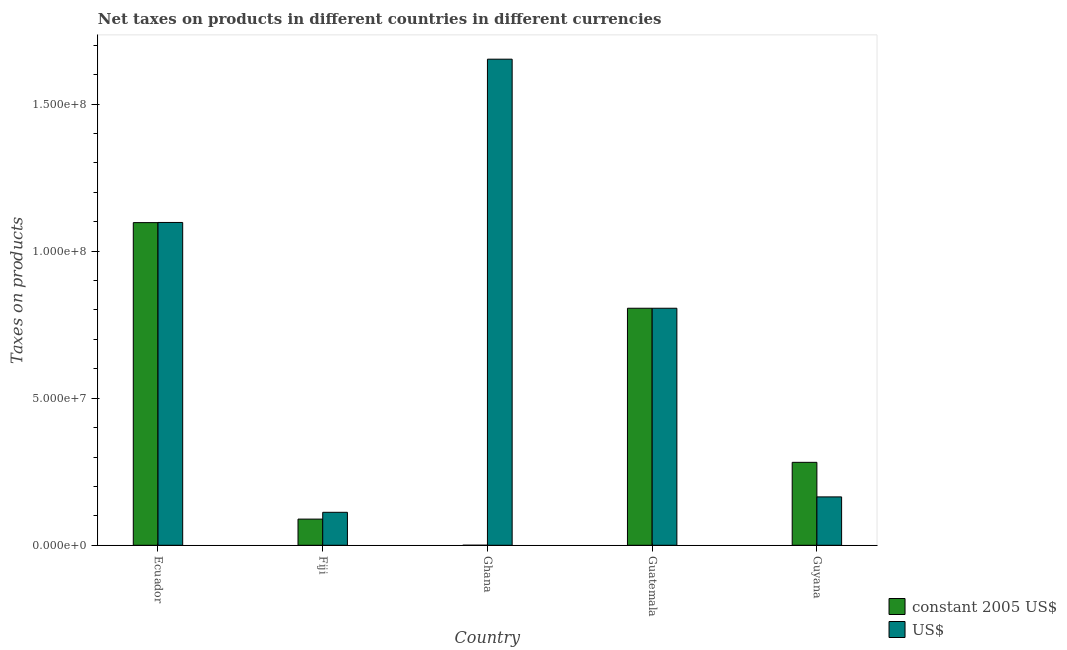How many different coloured bars are there?
Offer a very short reply. 2. How many groups of bars are there?
Keep it short and to the point. 5. How many bars are there on the 3rd tick from the left?
Offer a terse response. 2. How many bars are there on the 1st tick from the right?
Offer a terse response. 2. What is the label of the 4th group of bars from the left?
Your answer should be very brief. Guatemala. In how many cases, is the number of bars for a given country not equal to the number of legend labels?
Keep it short and to the point. 0. What is the net taxes in constant 2005 us$ in Guatemala?
Provide a short and direct response. 8.06e+07. Across all countries, what is the maximum net taxes in constant 2005 us$?
Your answer should be compact. 1.10e+08. Across all countries, what is the minimum net taxes in us$?
Keep it short and to the point. 1.12e+07. In which country was the net taxes in us$ maximum?
Give a very brief answer. Ghana. In which country was the net taxes in us$ minimum?
Your response must be concise. Fiji. What is the total net taxes in us$ in the graph?
Offer a terse response. 3.83e+08. What is the difference between the net taxes in us$ in Ecuador and that in Fiji?
Make the answer very short. 9.86e+07. What is the difference between the net taxes in us$ in Fiji and the net taxes in constant 2005 us$ in Guatemala?
Make the answer very short. -6.94e+07. What is the average net taxes in constant 2005 us$ per country?
Your response must be concise. 4.55e+07. What is the difference between the net taxes in us$ and net taxes in constant 2005 us$ in Fiji?
Provide a short and direct response. 2.31e+06. In how many countries, is the net taxes in constant 2005 us$ greater than 40000000 units?
Make the answer very short. 2. What is the ratio of the net taxes in constant 2005 us$ in Ecuador to that in Guatemala?
Offer a terse response. 1.36. Is the net taxes in constant 2005 us$ in Fiji less than that in Guyana?
Your answer should be compact. Yes. Is the difference between the net taxes in us$ in Ecuador and Ghana greater than the difference between the net taxes in constant 2005 us$ in Ecuador and Ghana?
Give a very brief answer. No. What is the difference between the highest and the second highest net taxes in constant 2005 us$?
Provide a succinct answer. 2.91e+07. What is the difference between the highest and the lowest net taxes in us$?
Keep it short and to the point. 1.54e+08. In how many countries, is the net taxes in us$ greater than the average net taxes in us$ taken over all countries?
Ensure brevity in your answer.  3. What does the 2nd bar from the left in Guatemala represents?
Offer a terse response. US$. What does the 2nd bar from the right in Ecuador represents?
Offer a very short reply. Constant 2005 us$. How many bars are there?
Give a very brief answer. 10. Are all the bars in the graph horizontal?
Ensure brevity in your answer.  No. How many countries are there in the graph?
Make the answer very short. 5. What is the difference between two consecutive major ticks on the Y-axis?
Your answer should be very brief. 5.00e+07. Are the values on the major ticks of Y-axis written in scientific E-notation?
Your answer should be compact. Yes. What is the title of the graph?
Keep it short and to the point. Net taxes on products in different countries in different currencies. Does "Commercial service exports" appear as one of the legend labels in the graph?
Provide a succinct answer. No. What is the label or title of the Y-axis?
Your response must be concise. Taxes on products. What is the Taxes on products of constant 2005 US$ in Ecuador?
Ensure brevity in your answer.  1.10e+08. What is the Taxes on products in US$ in Ecuador?
Make the answer very short. 1.10e+08. What is the Taxes on products of constant 2005 US$ in Fiji?
Ensure brevity in your answer.  8.90e+06. What is the Taxes on products in US$ in Fiji?
Your answer should be very brief. 1.12e+07. What is the Taxes on products in constant 2005 US$ in Ghana?
Your answer should be compact. 1.18e+04. What is the Taxes on products in US$ in Ghana?
Give a very brief answer. 1.65e+08. What is the Taxes on products in constant 2005 US$ in Guatemala?
Ensure brevity in your answer.  8.06e+07. What is the Taxes on products of US$ in Guatemala?
Your answer should be compact. 8.06e+07. What is the Taxes on products of constant 2005 US$ in Guyana?
Give a very brief answer. 2.82e+07. What is the Taxes on products of US$ in Guyana?
Provide a short and direct response. 1.64e+07. Across all countries, what is the maximum Taxes on products of constant 2005 US$?
Give a very brief answer. 1.10e+08. Across all countries, what is the maximum Taxes on products of US$?
Provide a short and direct response. 1.65e+08. Across all countries, what is the minimum Taxes on products in constant 2005 US$?
Keep it short and to the point. 1.18e+04. Across all countries, what is the minimum Taxes on products in US$?
Your answer should be very brief. 1.12e+07. What is the total Taxes on products in constant 2005 US$ in the graph?
Make the answer very short. 2.27e+08. What is the total Taxes on products of US$ in the graph?
Offer a terse response. 3.83e+08. What is the difference between the Taxes on products in constant 2005 US$ in Ecuador and that in Fiji?
Your response must be concise. 1.01e+08. What is the difference between the Taxes on products of US$ in Ecuador and that in Fiji?
Give a very brief answer. 9.86e+07. What is the difference between the Taxes on products in constant 2005 US$ in Ecuador and that in Ghana?
Keep it short and to the point. 1.10e+08. What is the difference between the Taxes on products in US$ in Ecuador and that in Ghana?
Provide a short and direct response. -5.55e+07. What is the difference between the Taxes on products in constant 2005 US$ in Ecuador and that in Guatemala?
Keep it short and to the point. 2.91e+07. What is the difference between the Taxes on products of US$ in Ecuador and that in Guatemala?
Your answer should be compact. 2.92e+07. What is the difference between the Taxes on products of constant 2005 US$ in Ecuador and that in Guyana?
Keep it short and to the point. 8.15e+07. What is the difference between the Taxes on products of US$ in Ecuador and that in Guyana?
Your answer should be compact. 9.33e+07. What is the difference between the Taxes on products of constant 2005 US$ in Fiji and that in Ghana?
Ensure brevity in your answer.  8.89e+06. What is the difference between the Taxes on products in US$ in Fiji and that in Ghana?
Your response must be concise. -1.54e+08. What is the difference between the Taxes on products in constant 2005 US$ in Fiji and that in Guatemala?
Offer a very short reply. -7.17e+07. What is the difference between the Taxes on products in US$ in Fiji and that in Guatemala?
Your answer should be very brief. -6.94e+07. What is the difference between the Taxes on products of constant 2005 US$ in Fiji and that in Guyana?
Offer a terse response. -1.93e+07. What is the difference between the Taxes on products in US$ in Fiji and that in Guyana?
Give a very brief answer. -5.24e+06. What is the difference between the Taxes on products in constant 2005 US$ in Ghana and that in Guatemala?
Give a very brief answer. -8.06e+07. What is the difference between the Taxes on products of US$ in Ghana and that in Guatemala?
Your answer should be compact. 8.47e+07. What is the difference between the Taxes on products in constant 2005 US$ in Ghana and that in Guyana?
Your answer should be compact. -2.82e+07. What is the difference between the Taxes on products of US$ in Ghana and that in Guyana?
Provide a succinct answer. 1.49e+08. What is the difference between the Taxes on products of constant 2005 US$ in Guatemala and that in Guyana?
Make the answer very short. 5.24e+07. What is the difference between the Taxes on products of US$ in Guatemala and that in Guyana?
Your answer should be compact. 6.42e+07. What is the difference between the Taxes on products of constant 2005 US$ in Ecuador and the Taxes on products of US$ in Fiji?
Provide a short and direct response. 9.85e+07. What is the difference between the Taxes on products of constant 2005 US$ in Ecuador and the Taxes on products of US$ in Ghana?
Your response must be concise. -5.56e+07. What is the difference between the Taxes on products of constant 2005 US$ in Ecuador and the Taxes on products of US$ in Guatemala?
Offer a very short reply. 2.91e+07. What is the difference between the Taxes on products in constant 2005 US$ in Ecuador and the Taxes on products in US$ in Guyana?
Your answer should be very brief. 9.33e+07. What is the difference between the Taxes on products of constant 2005 US$ in Fiji and the Taxes on products of US$ in Ghana?
Your answer should be very brief. -1.56e+08. What is the difference between the Taxes on products in constant 2005 US$ in Fiji and the Taxes on products in US$ in Guatemala?
Offer a terse response. -7.17e+07. What is the difference between the Taxes on products of constant 2005 US$ in Fiji and the Taxes on products of US$ in Guyana?
Offer a very short reply. -7.55e+06. What is the difference between the Taxes on products of constant 2005 US$ in Ghana and the Taxes on products of US$ in Guatemala?
Your answer should be very brief. -8.06e+07. What is the difference between the Taxes on products in constant 2005 US$ in Ghana and the Taxes on products in US$ in Guyana?
Give a very brief answer. -1.64e+07. What is the difference between the Taxes on products in constant 2005 US$ in Guatemala and the Taxes on products in US$ in Guyana?
Your answer should be very brief. 6.42e+07. What is the average Taxes on products in constant 2005 US$ per country?
Make the answer very short. 4.55e+07. What is the average Taxes on products in US$ per country?
Offer a very short reply. 7.67e+07. What is the difference between the Taxes on products in constant 2005 US$ and Taxes on products in US$ in Ecuador?
Your answer should be compact. -5.26e+04. What is the difference between the Taxes on products in constant 2005 US$ and Taxes on products in US$ in Fiji?
Keep it short and to the point. -2.31e+06. What is the difference between the Taxes on products of constant 2005 US$ and Taxes on products of US$ in Ghana?
Your answer should be very brief. -1.65e+08. What is the difference between the Taxes on products of constant 2005 US$ and Taxes on products of US$ in Guatemala?
Ensure brevity in your answer.  0. What is the difference between the Taxes on products of constant 2005 US$ and Taxes on products of US$ in Guyana?
Your response must be concise. 1.18e+07. What is the ratio of the Taxes on products in constant 2005 US$ in Ecuador to that in Fiji?
Ensure brevity in your answer.  12.33. What is the ratio of the Taxes on products in US$ in Ecuador to that in Fiji?
Give a very brief answer. 9.79. What is the ratio of the Taxes on products in constant 2005 US$ in Ecuador to that in Ghana?
Your answer should be compact. 9297.53. What is the ratio of the Taxes on products of US$ in Ecuador to that in Ghana?
Offer a terse response. 0.66. What is the ratio of the Taxes on products in constant 2005 US$ in Ecuador to that in Guatemala?
Your answer should be very brief. 1.36. What is the ratio of the Taxes on products of US$ in Ecuador to that in Guatemala?
Offer a very short reply. 1.36. What is the ratio of the Taxes on products of constant 2005 US$ in Ecuador to that in Guyana?
Your response must be concise. 3.89. What is the ratio of the Taxes on products in US$ in Ecuador to that in Guyana?
Keep it short and to the point. 6.67. What is the ratio of the Taxes on products in constant 2005 US$ in Fiji to that in Ghana?
Your response must be concise. 754.24. What is the ratio of the Taxes on products in US$ in Fiji to that in Ghana?
Give a very brief answer. 0.07. What is the ratio of the Taxes on products in constant 2005 US$ in Fiji to that in Guatemala?
Provide a short and direct response. 0.11. What is the ratio of the Taxes on products of US$ in Fiji to that in Guatemala?
Give a very brief answer. 0.14. What is the ratio of the Taxes on products in constant 2005 US$ in Fiji to that in Guyana?
Give a very brief answer. 0.32. What is the ratio of the Taxes on products of US$ in Fiji to that in Guyana?
Provide a succinct answer. 0.68. What is the ratio of the Taxes on products in US$ in Ghana to that in Guatemala?
Offer a very short reply. 2.05. What is the ratio of the Taxes on products in US$ in Ghana to that in Guyana?
Give a very brief answer. 10.05. What is the ratio of the Taxes on products of constant 2005 US$ in Guatemala to that in Guyana?
Provide a succinct answer. 2.86. What is the ratio of the Taxes on products of US$ in Guatemala to that in Guyana?
Offer a terse response. 4.9. What is the difference between the highest and the second highest Taxes on products of constant 2005 US$?
Ensure brevity in your answer.  2.91e+07. What is the difference between the highest and the second highest Taxes on products of US$?
Your response must be concise. 5.55e+07. What is the difference between the highest and the lowest Taxes on products in constant 2005 US$?
Provide a short and direct response. 1.10e+08. What is the difference between the highest and the lowest Taxes on products in US$?
Your answer should be compact. 1.54e+08. 